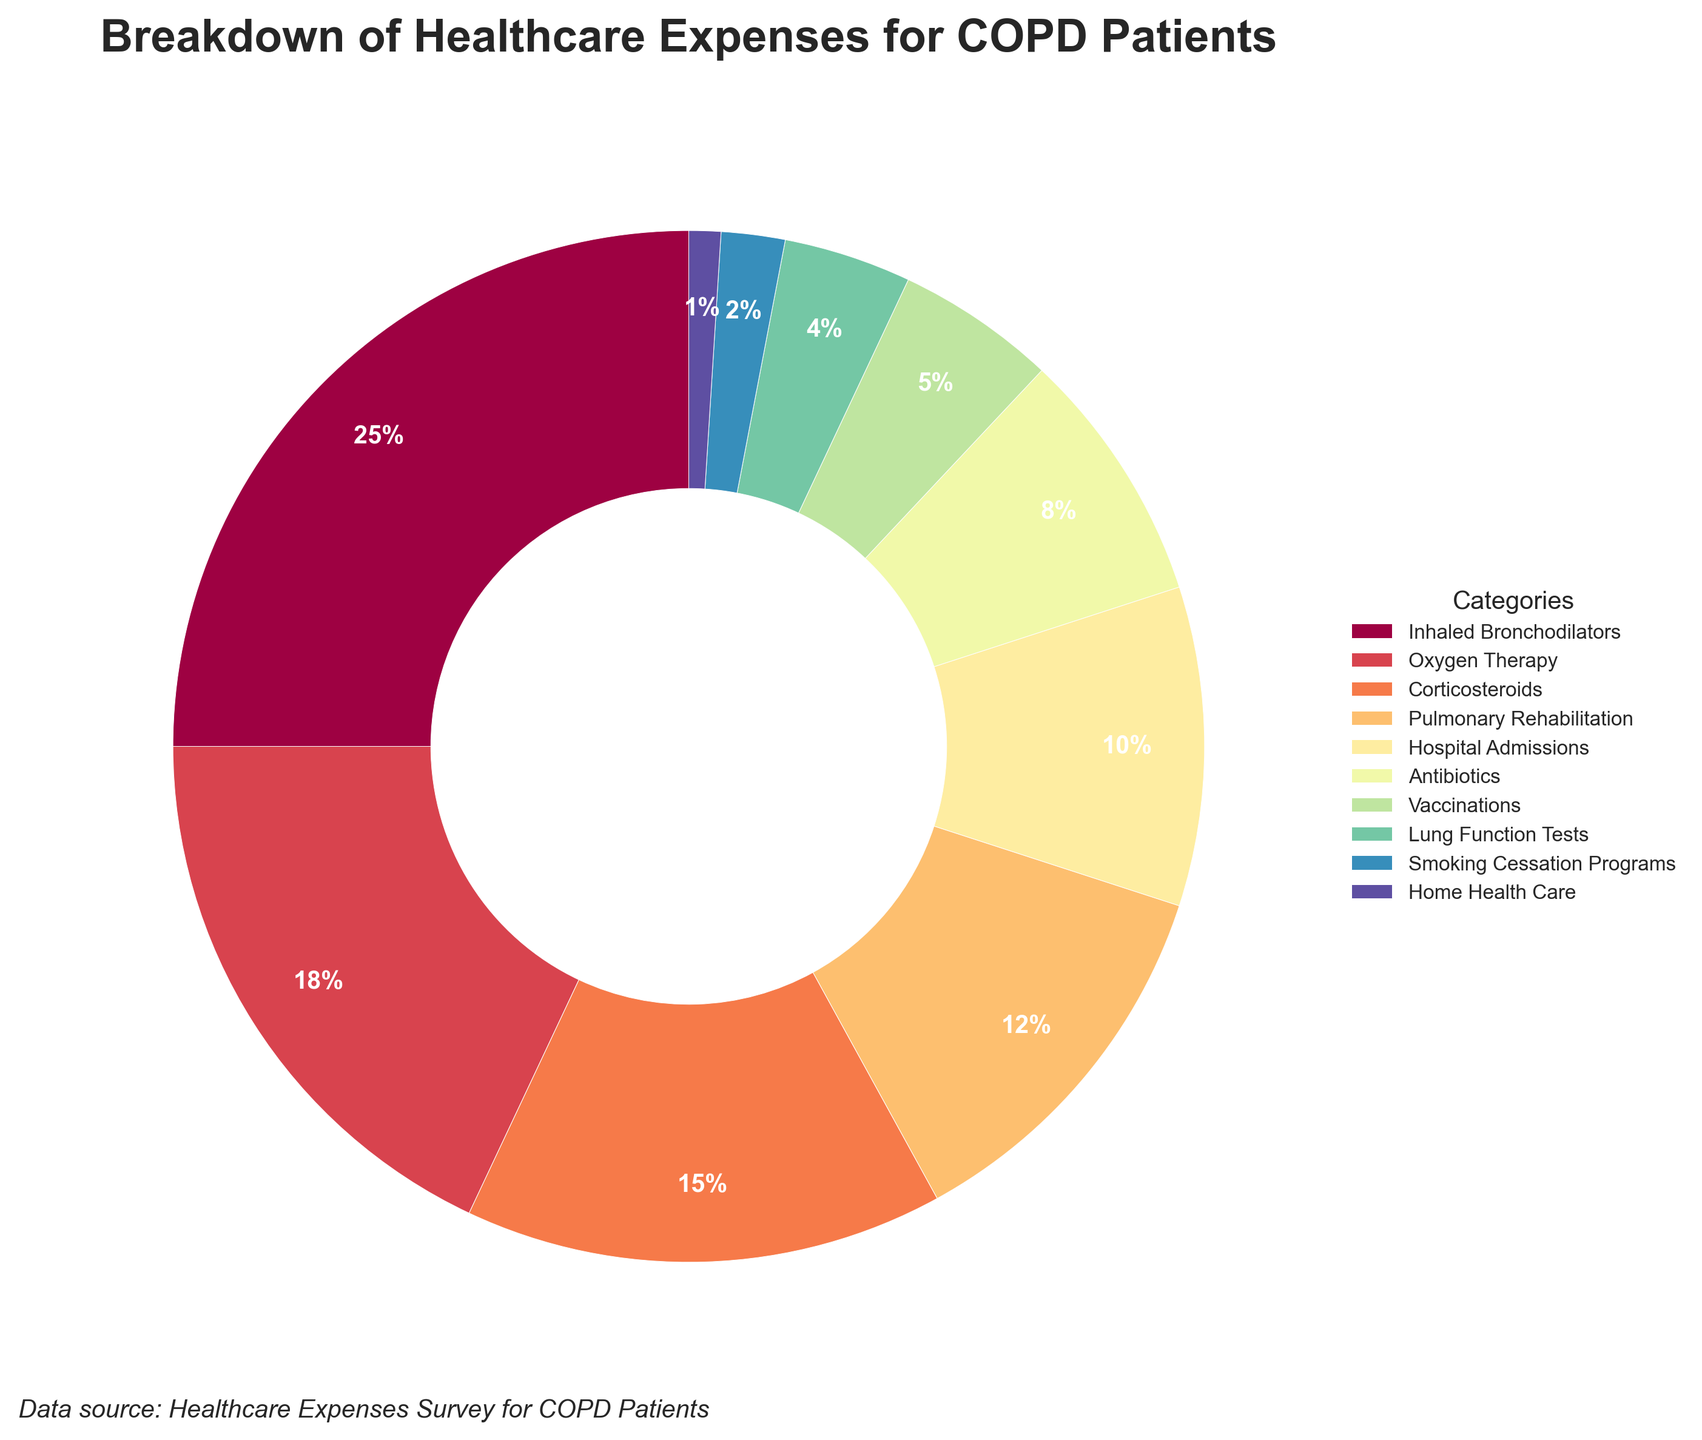What's the largest expenditure category? The largest expenditure category can be identified by looking at the percentage values of each category. The category with the highest percentage is Inhaled Bronchodilators at 25%.
Answer: Inhaled Bronchodilators Which two categories combined make up exactly 20% of the expenses? By summing the percentages of different categories, the categories that together equal exactly 20% are antibiotics (8%) and vaccinations (5%) plus lung function tests (4%) plus smoking cessation programs (2%) which total exactly 20%.
Answer: Antibiotics, Vaccinations, Lung Function Tests, Smoking Cessation Programs How do the inhaled bronchodilators compare to oxygen therapy in terms of expenses? The percentage of expenses for inhaled bronchodilators is 25% and for oxygen therapy is 18%. Comparing these, inhaled bronchodilators have a higher percentage than oxygen therapy.
Answer: Inhaled Bronchodilators > Oxygen Therapy Which category is represented by the smallest wedge in the pie chart? By visually inspecting the smallest wedge, it is the category with the smallest percentage. The smallest percentage is 1%, which corresponds to home health care.
Answer: Home Health Care What percentage of expenses is represented by pulmonary rehabilitation and hospital admissions combined? Adding the percentages for pulmonary rehabilitation (12%) and hospital admissions (10%), the combined expenses are 12% + 10% = 22%.
Answer: 22% Which five categories are associated with expenses less than 10% each? Categories with less than 10% costs are identified by their percentage values. The relevant categories are antibiotics (8%), vaccinations (5%), lung function tests (4%), smoking cessation programs (2%), and home health care (1%).
Answer: Antibiotics, Vaccinations, Lung Function Tests, Smoking Cessation Programs, Home Health Care Is the proportion of expenses on vaccinations greater than or less than that on lung function tests? Comparing the percentages for vaccinations (5%) and lung function tests (4%), vaccinations have a higher percentage than lung function tests.
Answer: Greater What is the cumulative percentage of expenses under medications, which include inhaled bronchodilators, corticosteroids, and antibiotics? Summing the percentages for inhaled bronchodilators (25%), corticosteroids (15%), and antibiotics (8%), the cumulative percentage is 25% + 15% + 8% = 48%.
Answer: 48% What visual cues identify the wedges representing the two highest expense categories in the pie chart? The two highest expenses would have the largest wedges. These wedges are separated visually by their larger sizes and in this chart are associated with the categories inhaled bronchodilators (25%) and oxygen therapy (18%).
Answer: Largest wedges What is the difference in percentage between the highest and the lowest expense categories? Subtracting the percentage of the lowest category, home health care (1%), from the highest category, inhaled bronchodilators (25%), the difference is 25% - 1% = 24%.
Answer: 24% 